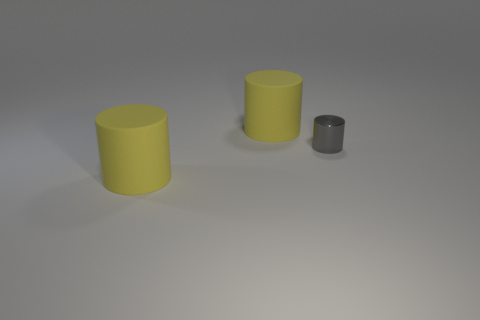What could these cylinders be used for? The cylinders in the image could serve various purposes depending on their material and context. If they are solid, they might be used as props or stands. If hollow, they could be containers or parts of a larger mechanism. The different sizes suggest they could nest inside each other or be used together in a complementary fashion. 